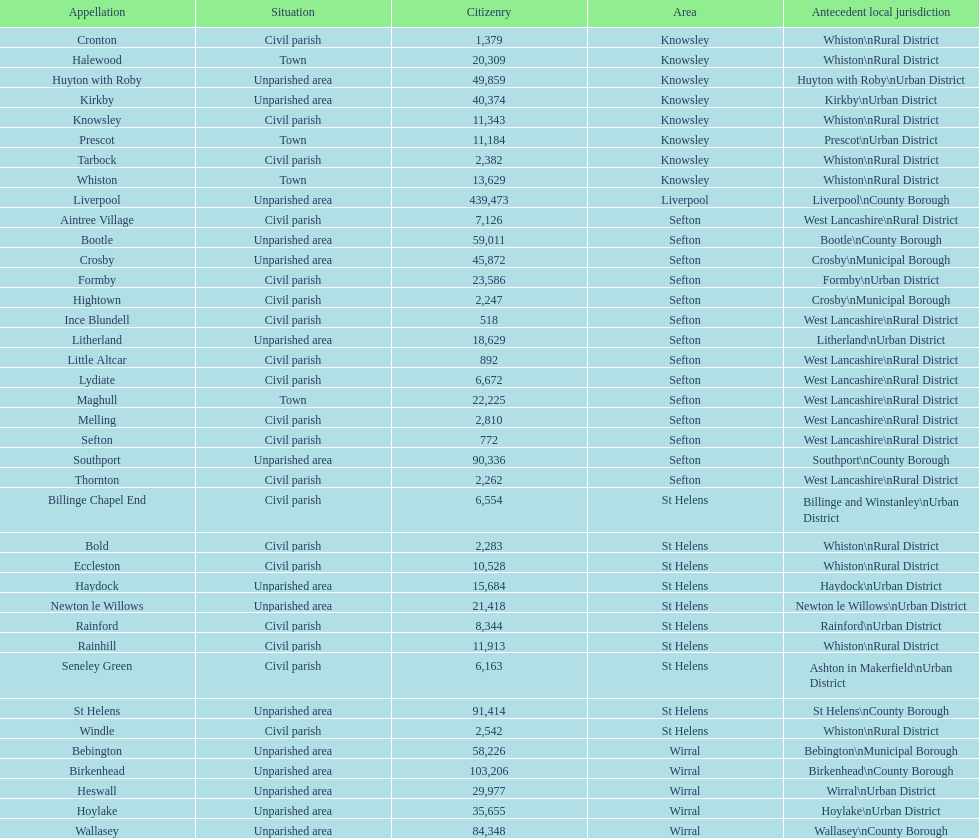How many individuals reside in the bold civil parish? 2,283. 